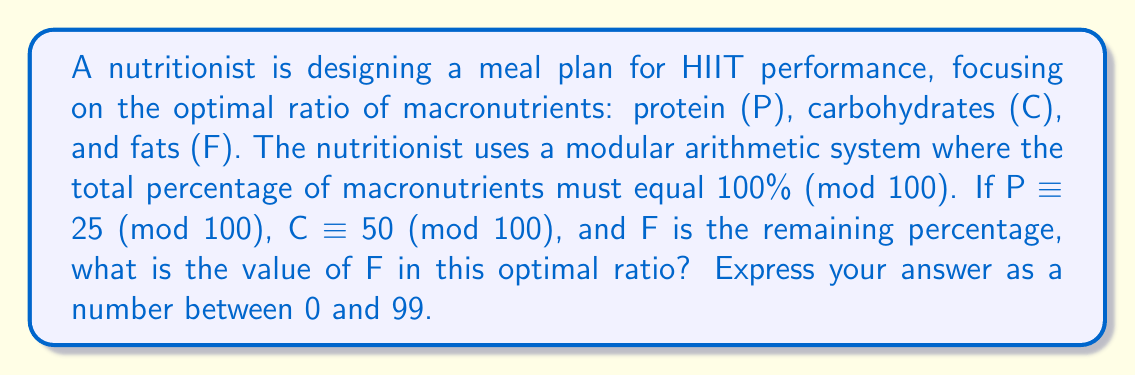What is the answer to this math problem? To solve this problem, we'll use the principles of modular arithmetic:

1) In modular arithmetic (mod 100), the sum of all components must be congruent to 0:
   $$(P + C + F) \equiv 0 \pmod{100}$$

2) We're given that:
   $$P \equiv 25 \pmod{100}$$
   $$C \equiv 50 \pmod{100}$$

3) Substituting these values into the equation from step 1:
   $$(25 + 50 + F) \equiv 0 \pmod{100}$$

4) Simplify the left side:
   $$(75 + F) \equiv 0 \pmod{100}$$

5) To solve for F, we need to find a number that, when added to 75, results in a multiple of 100. This number is 25:
   $$75 + 25 = 100 \equiv 0 \pmod{100}$$

6) Therefore:
   $$F \equiv 25 \pmod{100}$$

The value of F that satisfies this congruence and is between 0 and 99 is 25.
Answer: 25 